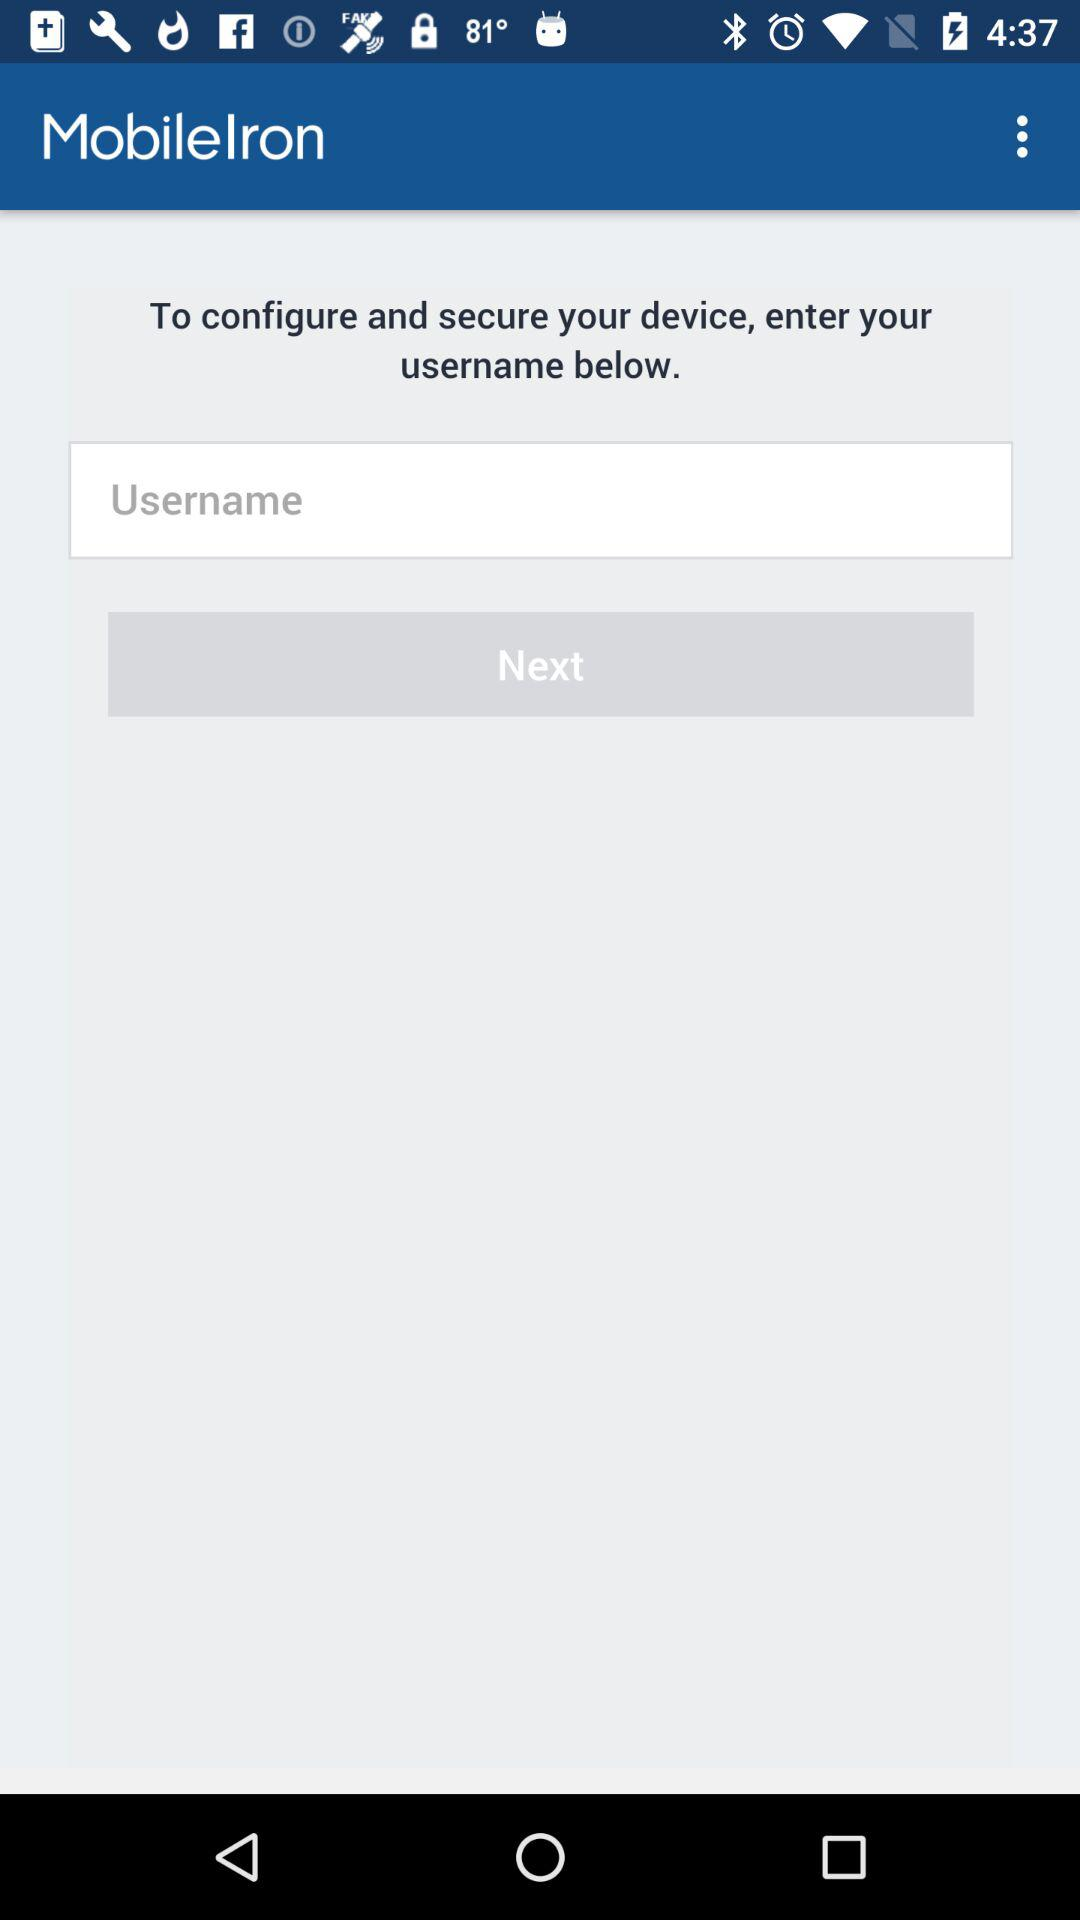What is required to configure and secure the device? To configure and secure the device, a username is required. 